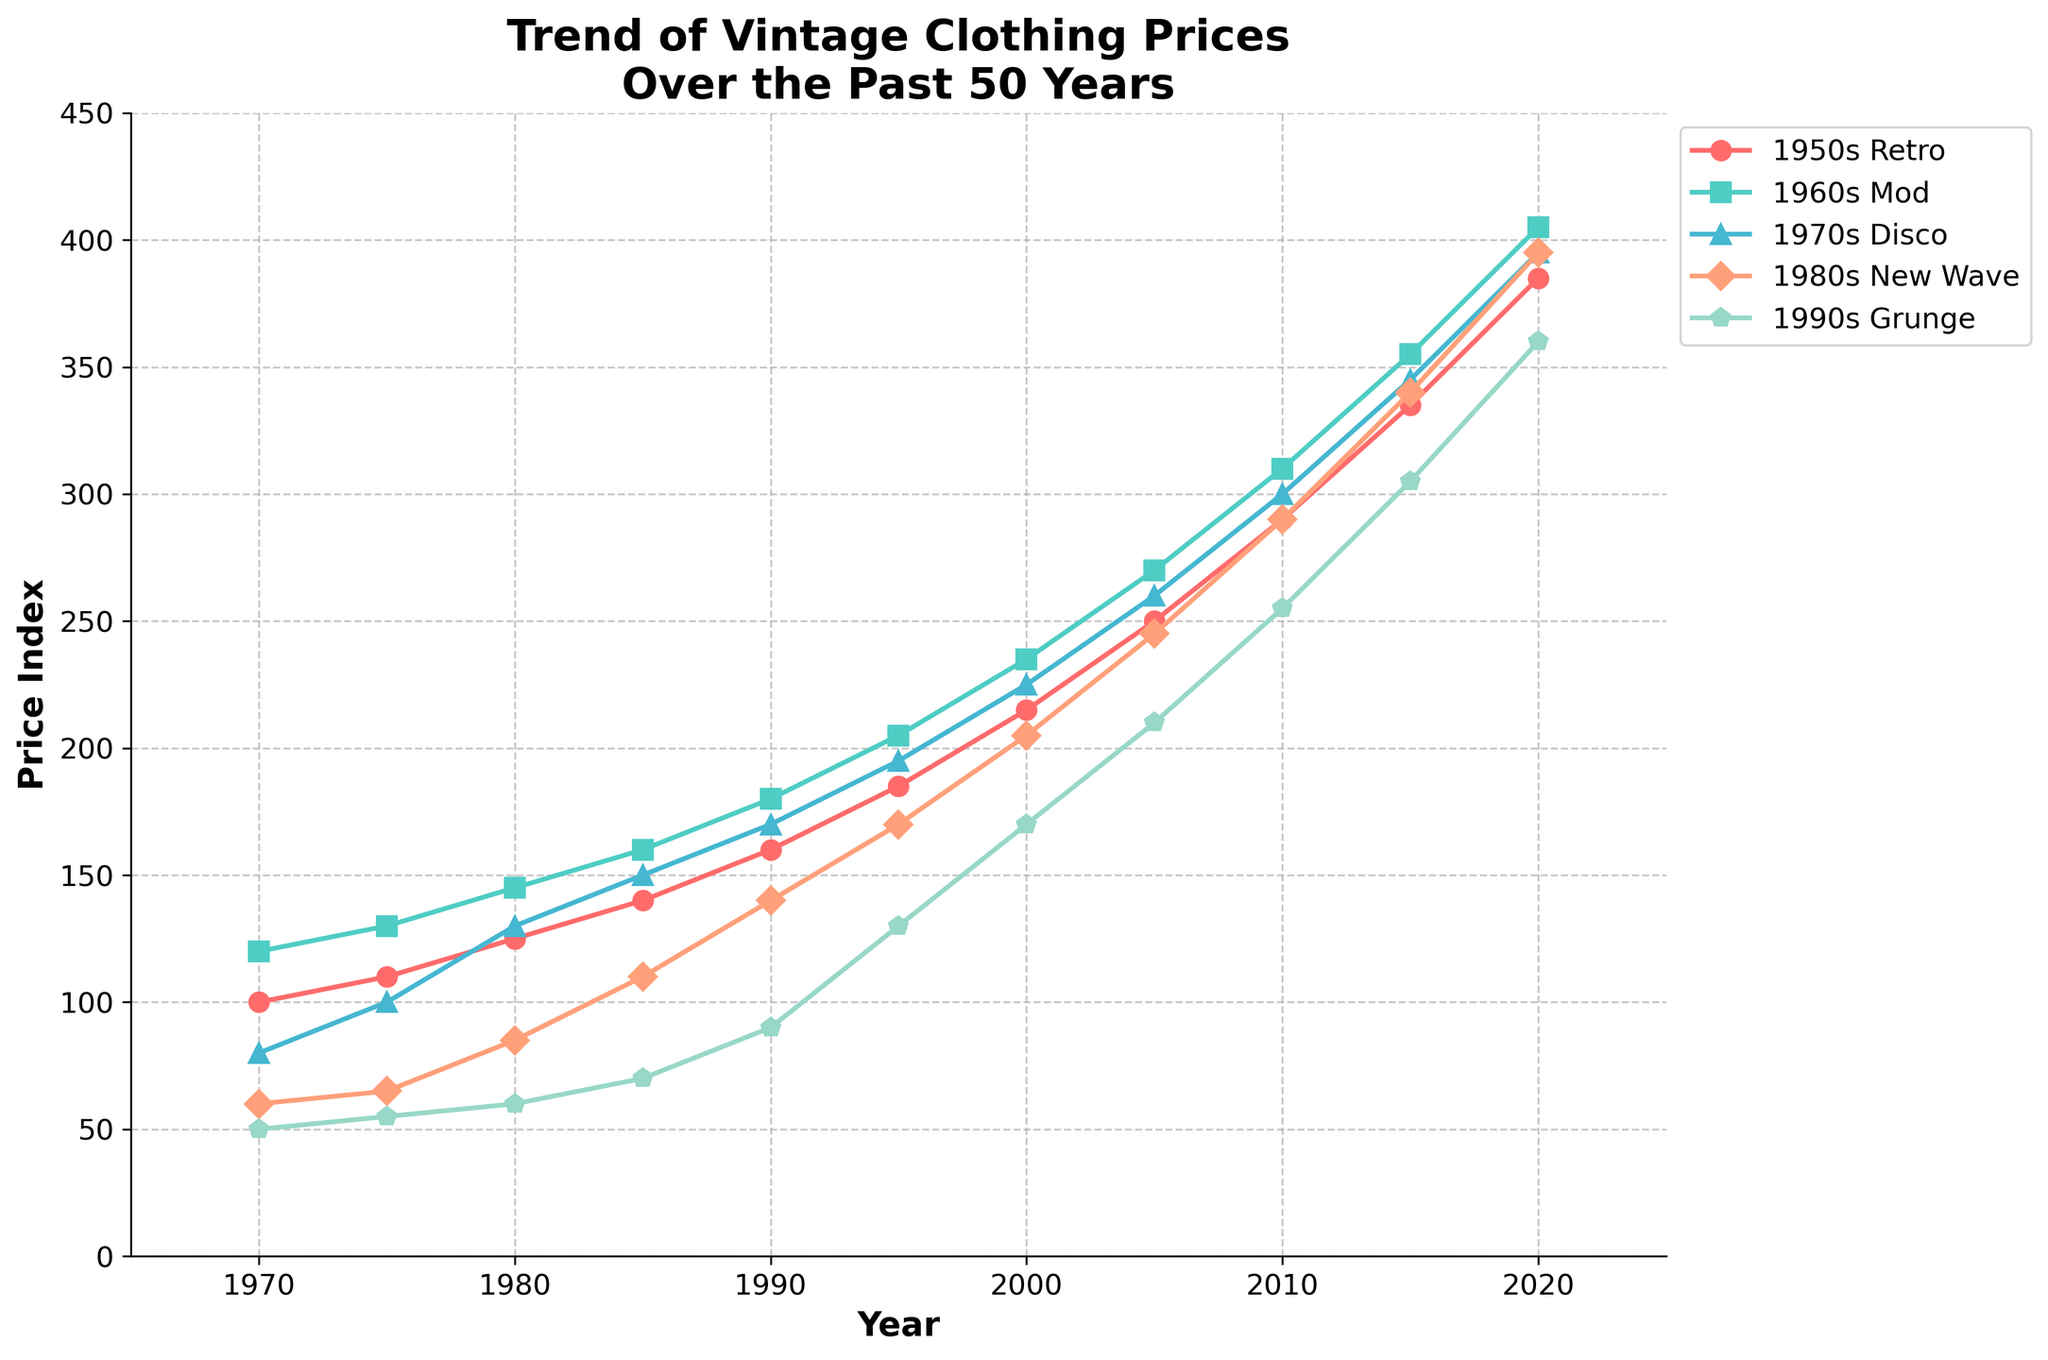Which fashion era had the highest price index in 2020? Look at the end of the graph for the year 2020. The highest point corresponds to the '1950s Retro' era.
Answer: 1950s Retro By how much did the price index for the 1980s New Wave era increase from 1990 to 2010? Find the value of the 1980s New Wave era in 1990 (140) and in 2010 (290). The increase is 290 - 140.
Answer: 150 Which era experienced the largest overall increase in price index from 1970 to 2020? Compare the difference between 1970 and 2020 values for each era: 
- 1950s Retro: 385 - 100 = 285 
- 1960s Mod: 405 - 120 = 285
- 1970s Disco: 395 - 80 = 315
- 1980s New Wave: 395 - 60 = 335
- 1990s Grunge: 360 - 50 = 310 
The 1980s New Wave had the largest increase.
Answer: 1980s New Wave In which year did the price index for the 1960s Mod era reach 205? Find the year corresponding to the value 205 in the 1960s Mod era line. It intersects at the year 1995.
Answer: 1995 What was the price index of the 1970s Disco era in 1980 and how does it compare to that of the 1990s Grunge era in the same year? Which was higher? Look at the values for the 1970s Disco (130) and the 1990s Grunge (60) eras in 1980. The 1970s Disco era's value is higher.
Answer: 1970s Disco By what percentage did the price index of the 1950s Retro era change from 2000 to 2010? Calculate the values for the 1950s Retro era in 2000 (215) and in 2010 (290). Percentage change = ((290 - 215) / 215) * 100.
Answer: 34.88% Which era had the steepest price index increase between 2000 and 2005? Compare the slopes between 2000 and 2005 for each era:
- 1950s Retro: 250 - 215 = 35
- 1960s Mod: 270 - 235 = 35
- 1970s Disco: 260 - 225 = 35
- 1980s New Wave: 245 - 205 = 40
- 1990s Grunge: 210 - 170 = 40 
The steepest increase is tied between the 1980s New Wave and the 1990s Grunge.
Answer: 1980s New Wave and 1990s Grunge Between 1995 and 2000, which era saw the smallest increase in price index? Compare the increases for each era from 1995 to 2000:
- 1950s Retro: 215 - 185 = 30
- 1960s Mod: 235 - 205 = 30
- 1970s Disco: 225 - 195 = 30
- 1980s New Wave: 205 - 170 = 35
- 1990s Grunge: 170 - 130 = 40 
The smallest increase is tied between the 1950s Retro, 1960s Mod, and 1970s Disco.
Answer: 1950s Retro, 1960s Mod, and 1970s Disco 